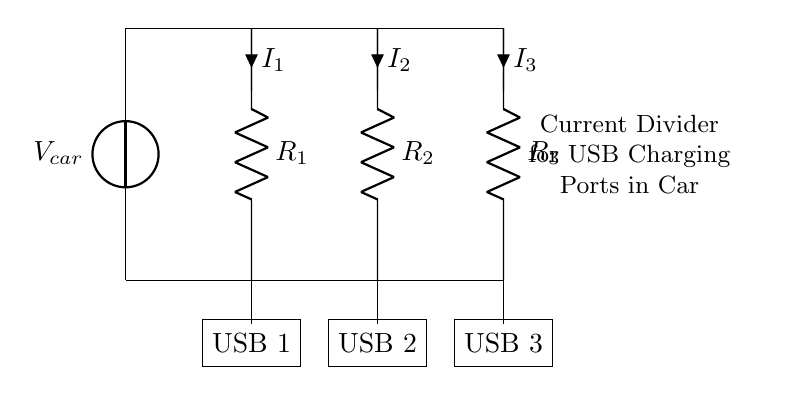What is the type of power source used in this circuit? The circuit uses a voltage source labeled as V_car, indicating that it is powered by the car's electrical system.
Answer: V_car How many USB charging ports are connected in this circuit? The diagram shows three USB rectangles labeled as USB 1, USB 2, and USB 3, indicating that there are three ports.
Answer: 3 What are the resistors labeled in the circuit? The resistors in the circuit are labeled as R_1, R_2, and R_3. Each resistor is connected to a corresponding USB port for current distribution.
Answer: R_1, R_2, R_3 What can you infer about the current flowing to each USB port? This is a current divider circuit, meaning the total current is divided among the three resistors; therefore, each USB port receives a fraction of the total current.
Answer: Divided Which USB port is connected to the resistor R_2? The USB port labeled as USB 2 is connected to the resistor R_2, as it is positioned below it in the circuit diagram.
Answer: USB 2 If R_1 has the lowest resistance, which USB port receives the most current? According to the current divider principle, the port connected to the resistor with the lowest resistance (in this case, R_1) will receive the most current. Hence, USB 1 receives the most current.
Answer: USB 1 What does the notation "i" represent in the diagram? The notation "i" represents the current flowing through each respective resistor connecting to each USB port. Each port has its own current labeled as I_1, I_2, and I_3.
Answer: Current (i) 